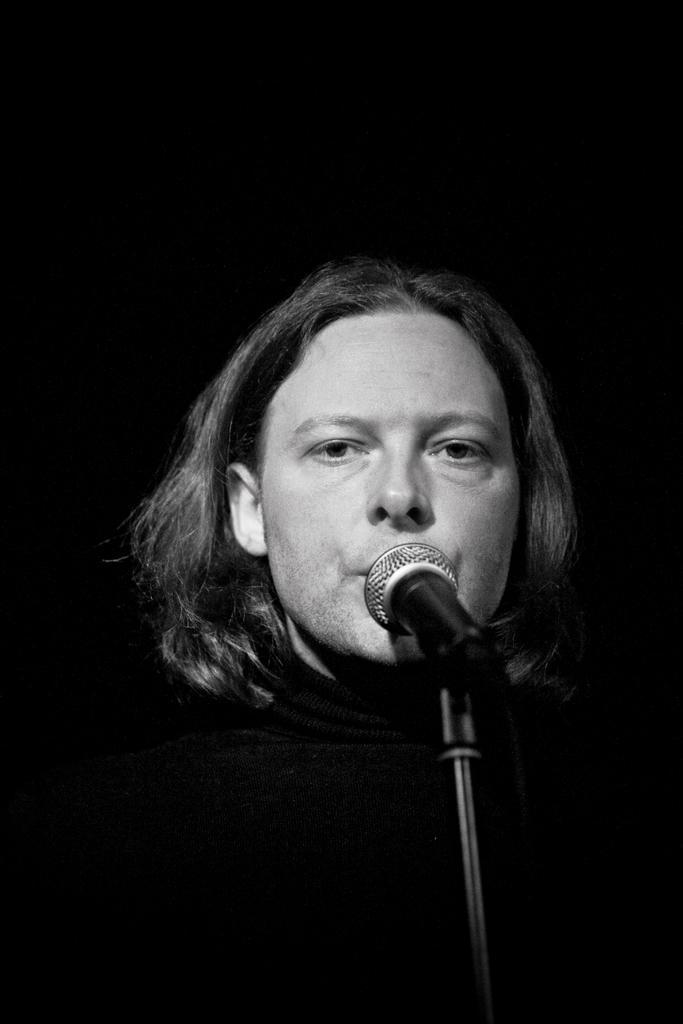Please provide a concise description of this image. In this image we can see the person in front of the microphone and there is the dark background. 